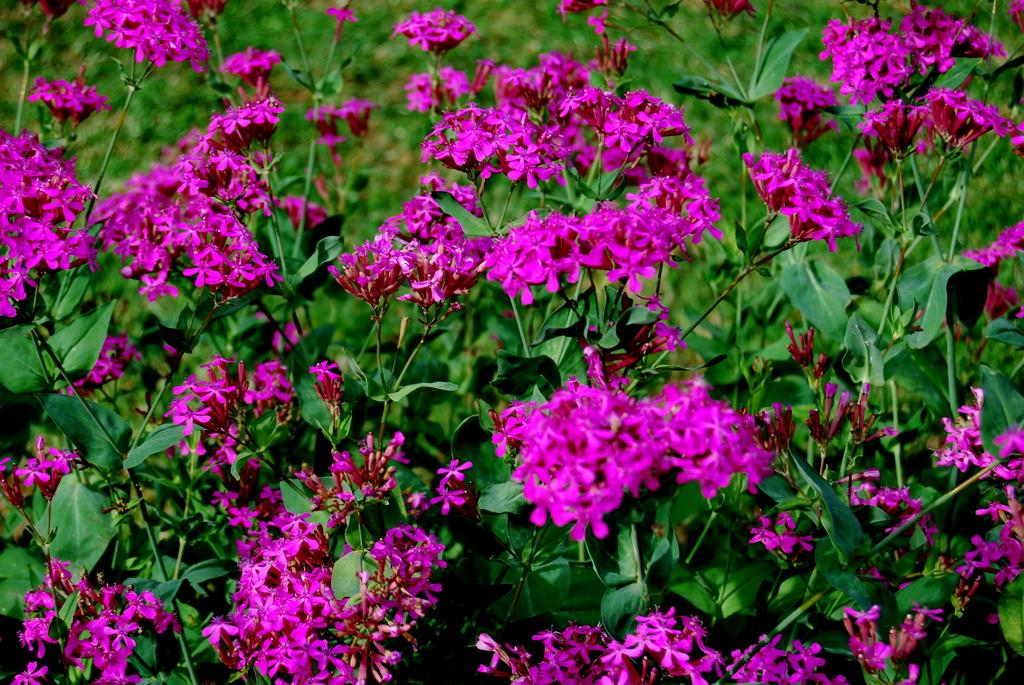What type of living organisms can be seen in the image? Plants can be seen in the image. Can you describe the flowers present in the image? There are pink color flowers in the image. Can you see any clouds in the image? There is no mention of clouds in the provided facts, and the image does not show any clouds, as it focuses on plants and flowers. 